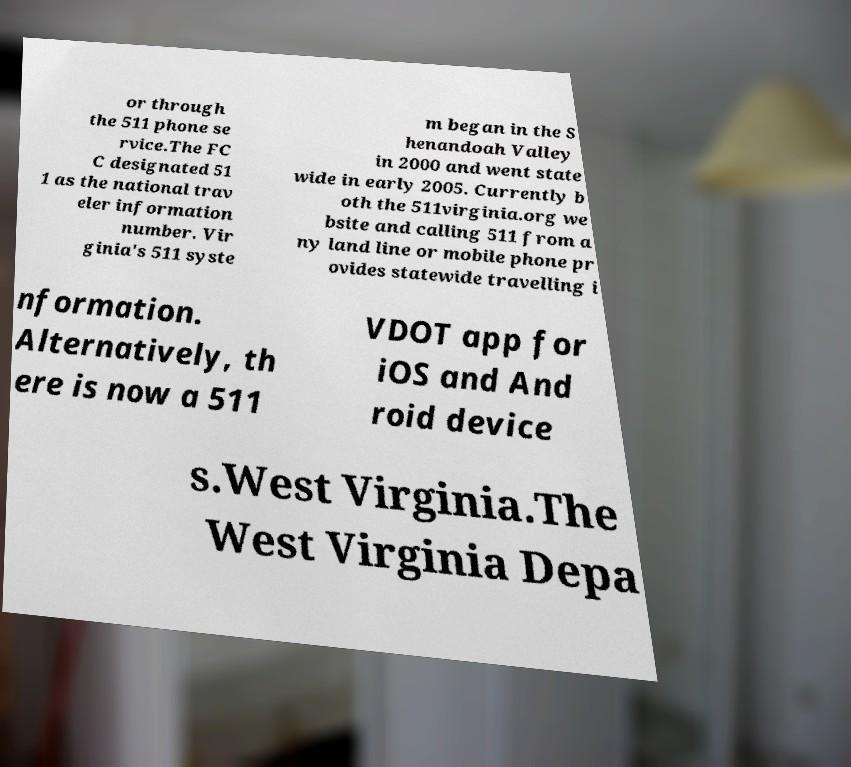Please read and relay the text visible in this image. What does it say? or through the 511 phone se rvice.The FC C designated 51 1 as the national trav eler information number. Vir ginia's 511 syste m began in the S henandoah Valley in 2000 and went state wide in early 2005. Currently b oth the 511virginia.org we bsite and calling 511 from a ny land line or mobile phone pr ovides statewide travelling i nformation. Alternatively, th ere is now a 511 VDOT app for iOS and And roid device s.West Virginia.The West Virginia Depa 